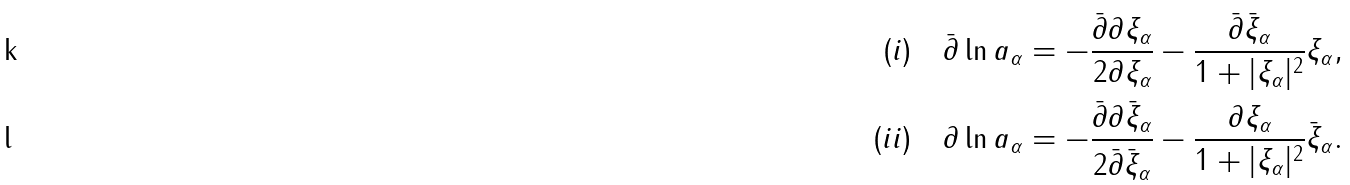Convert formula to latex. <formula><loc_0><loc_0><loc_500><loc_500>( i ) \quad \bar { \partial } \ln a _ { \alpha } = - \frac { \bar { \partial } \partial \xi _ { \alpha } } { 2 \partial \xi _ { \alpha } } - \frac { \bar { \partial } \bar { \xi } _ { \alpha } } { 1 + | \xi _ { \alpha } | ^ { 2 } } \xi _ { \alpha } , \\ ( i i ) \quad \partial \ln a _ { \alpha } = - \frac { \bar { \partial } \partial \bar { \xi } _ { \alpha } } { 2 \bar { \partial } \bar { \xi } _ { \alpha } } - \frac { \partial \xi _ { \alpha } } { 1 + | \xi _ { \alpha } | ^ { 2 } } \bar { \xi } _ { \alpha } .</formula> 